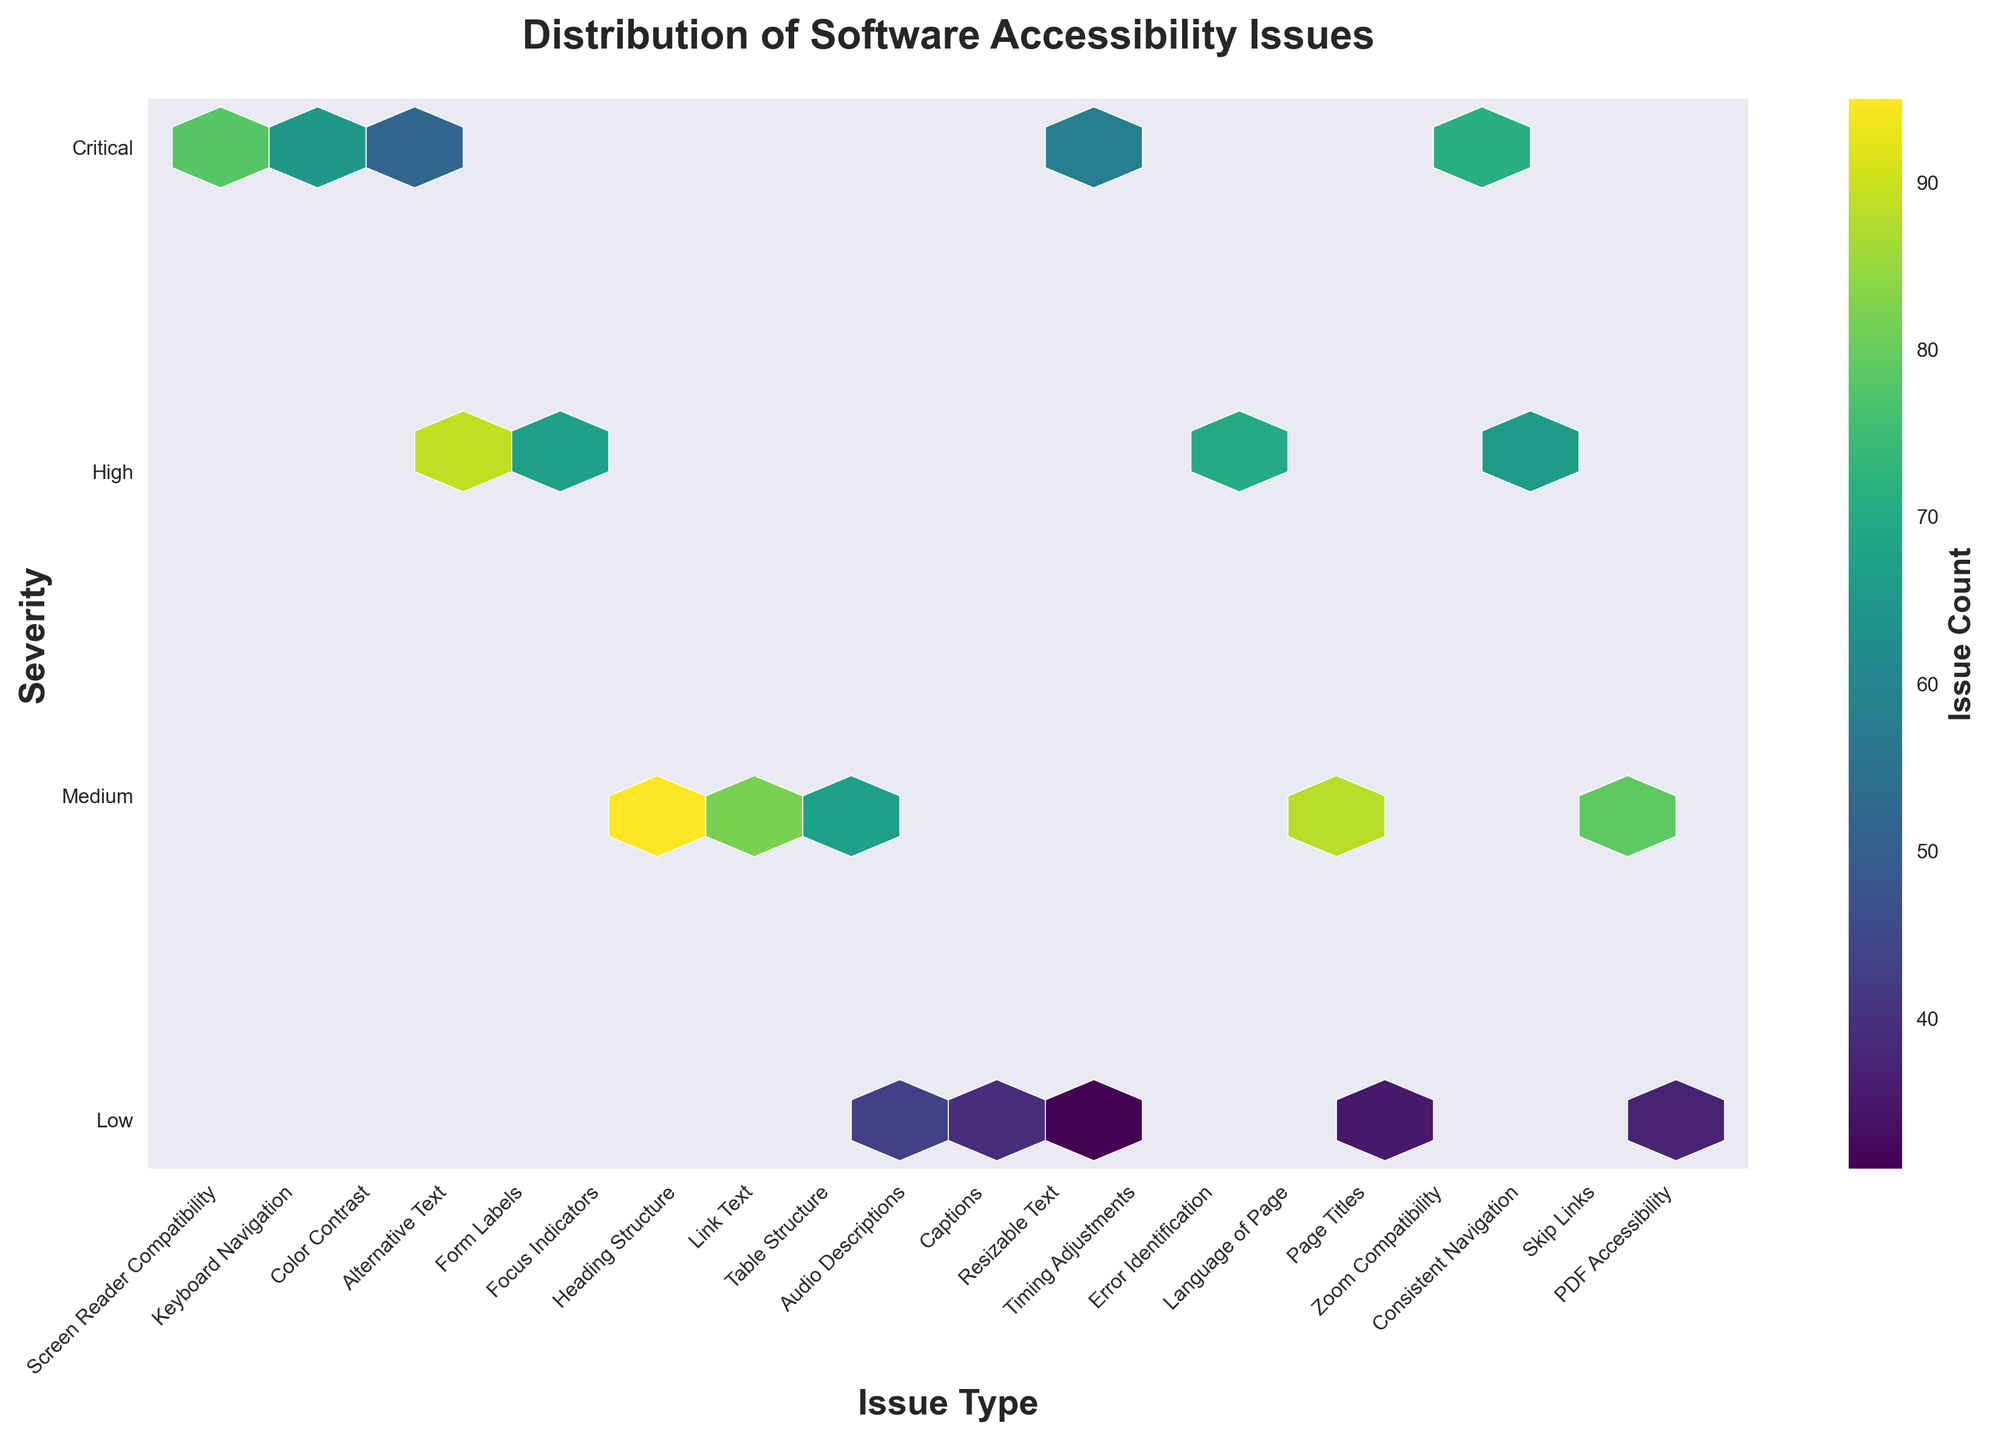What is the title of the plot? The title of the plot is positioned at the top and centers the main message in bold. It helps viewers understand what the visualization shows without looking at axes.
Answer: Distribution of Software Accessibility Issues What does the color intensity in the hexbin plot represent? The color intensity indicates the number of accessibility issues reported for a specific combination of severity and issue type. Darker colors denote higher counts.
Answer: Issue count Which severity level has the most variety of issue types reported? By examining the y-axis with the labels "Critical," "High," "Medium," and "Low," and counting how many unique hexagons appear for each, we can see which severity has the most issue types.
Answer: Medium What issue type has the highest count at the "Critical" severity level? Look at the top row of hexagons, which corresponds to "Critical" severity on the y-axis, and identify the darkest hexagon.
Answer: Screen Reader Compatibility How many unique issue types are there in total across all severity levels? Count all unique labels on the x-axis. Each label represents a different issue type.
Answer: 18 Which severity level has the least number of reported issue types? By counting the number of unique hexagons across the y-axis levels labeled "Low," "Medium," "High," and "Critical," we can identify the level with the least variety.
Answer: Low What issue type has the highest count at the "High" severity level? Look at the row of hexagons corresponding to the "High" severity on the y-axis and identify the darkest hexagon in that row, indicating the most frequent issue.
Answer: Alternative Text How does the "Critical" severity compare to "Medium" severity in terms of issue count for the "Timing Adjustments" issue type? Compare the color intensity (i.e., the count represented) for "Timing Adjustments" under both "Critical" and "Medium" severities on the y-axis.
Answer: Higher in Critical Which type of issues is most frequently reported in the "Low" severity category? Identify the darkest (most color-intense) hexagon in the row labeled "Low" on the y-axis to find the most frequent issue type at this severity level.
Answer: Audio Descriptions 